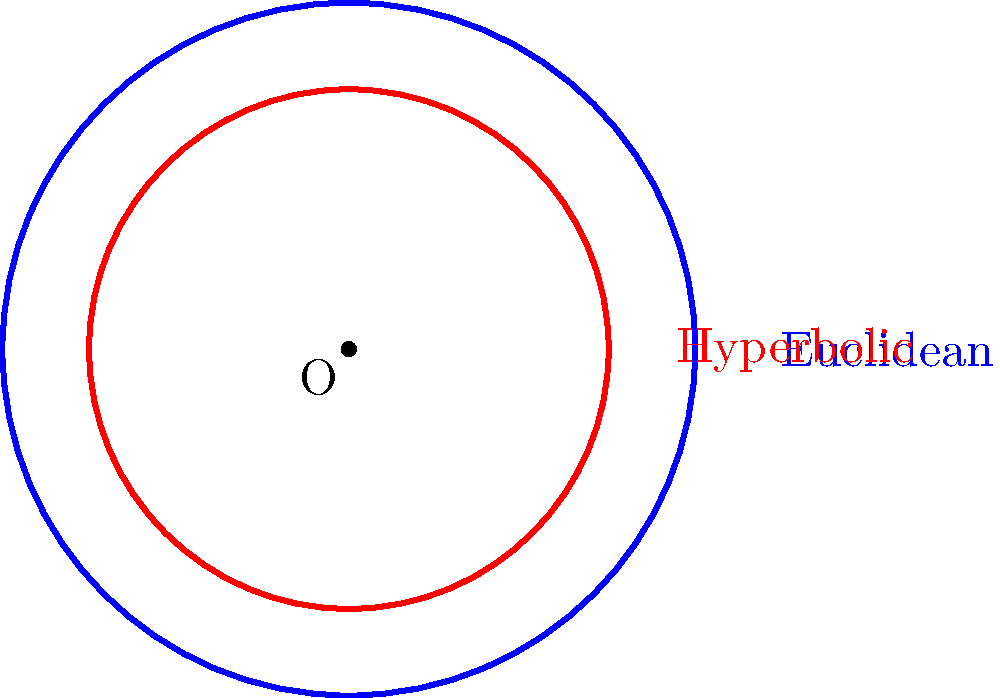In the context of blockchain's decentralized nature, consider the comparison between Euclidean and hyperbolic geometry. The diagram shows two circles with the same radius in their respective geometries. If the area of the Euclidean circle is $A_E = \pi r^2$, and the area of the hyperbolic circle is $A_H = 4\pi \sinh^2(\frac{r}{2})$, what is the ratio of $\frac{A_H}{A_E}$ when $r = 2$? To solve this problem, we need to follow these steps:

1. Recall the given formulas:
   Euclidean circle area: $A_E = \pi r^2$
   Hyperbolic circle area: $A_H = 4\pi \sinh^2(\frac{r}{2})$

2. Calculate $A_E$ with $r = 2$:
   $A_E = \pi (2)^2 = 4\pi$

3. Calculate $A_H$ with $r = 2$:
   $A_H = 4\pi \sinh^2(\frac{2}{2}) = 4\pi \sinh^2(1)$

4. Calculate $\sinh(1)$:
   $\sinh(1) = \frac{e^1 - e^{-1}}{2} \approx 1.1752$

5. Substitute this value into $A_H$:
   $A_H = 4\pi (1.1752)^2 \approx 17.2866\pi$

6. Calculate the ratio $\frac{A_H}{A_E}$:
   $\frac{A_H}{A_E} = \frac{17.2866\pi}{4\pi} \approx 4.3217$

This ratio demonstrates that in hyperbolic geometry, the area of a circle grows much faster with increasing radius compared to Euclidean geometry, which is analogous to how decentralized networks can scale more efficiently than centralized systems.
Answer: $\frac{A_H}{A_E} \approx 4.3217$ 